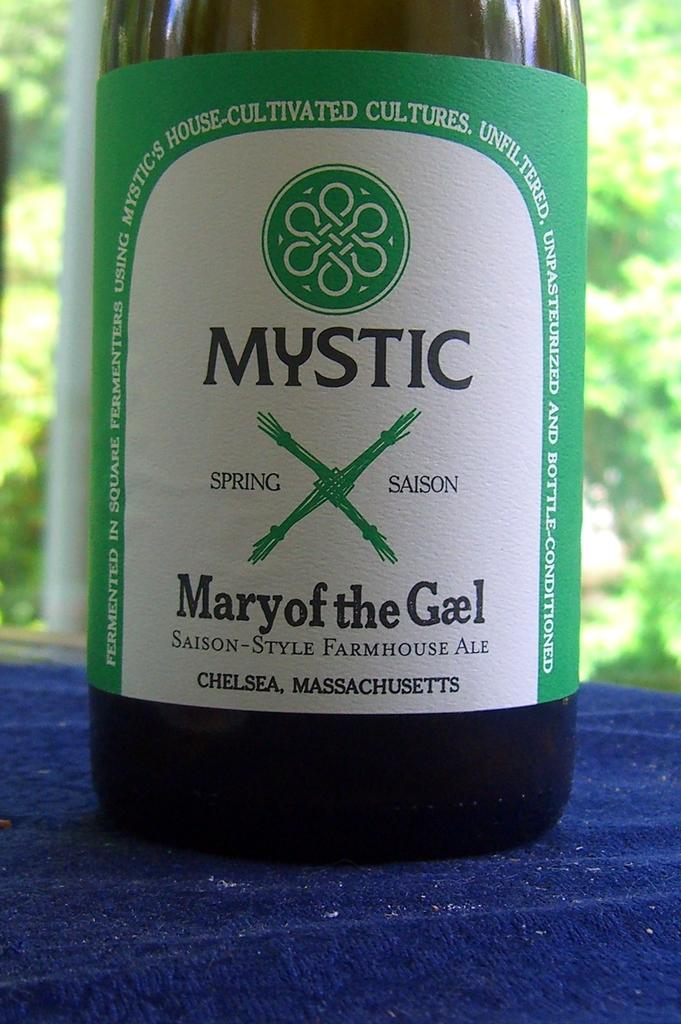<image>
Provide a brief description of the given image. the word mystic is on a bottle of gael 